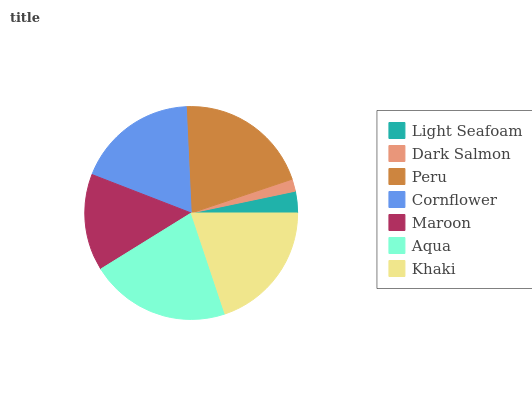Is Dark Salmon the minimum?
Answer yes or no. Yes. Is Aqua the maximum?
Answer yes or no. Yes. Is Peru the minimum?
Answer yes or no. No. Is Peru the maximum?
Answer yes or no. No. Is Peru greater than Dark Salmon?
Answer yes or no. Yes. Is Dark Salmon less than Peru?
Answer yes or no. Yes. Is Dark Salmon greater than Peru?
Answer yes or no. No. Is Peru less than Dark Salmon?
Answer yes or no. No. Is Cornflower the high median?
Answer yes or no. Yes. Is Cornflower the low median?
Answer yes or no. Yes. Is Dark Salmon the high median?
Answer yes or no. No. Is Light Seafoam the low median?
Answer yes or no. No. 